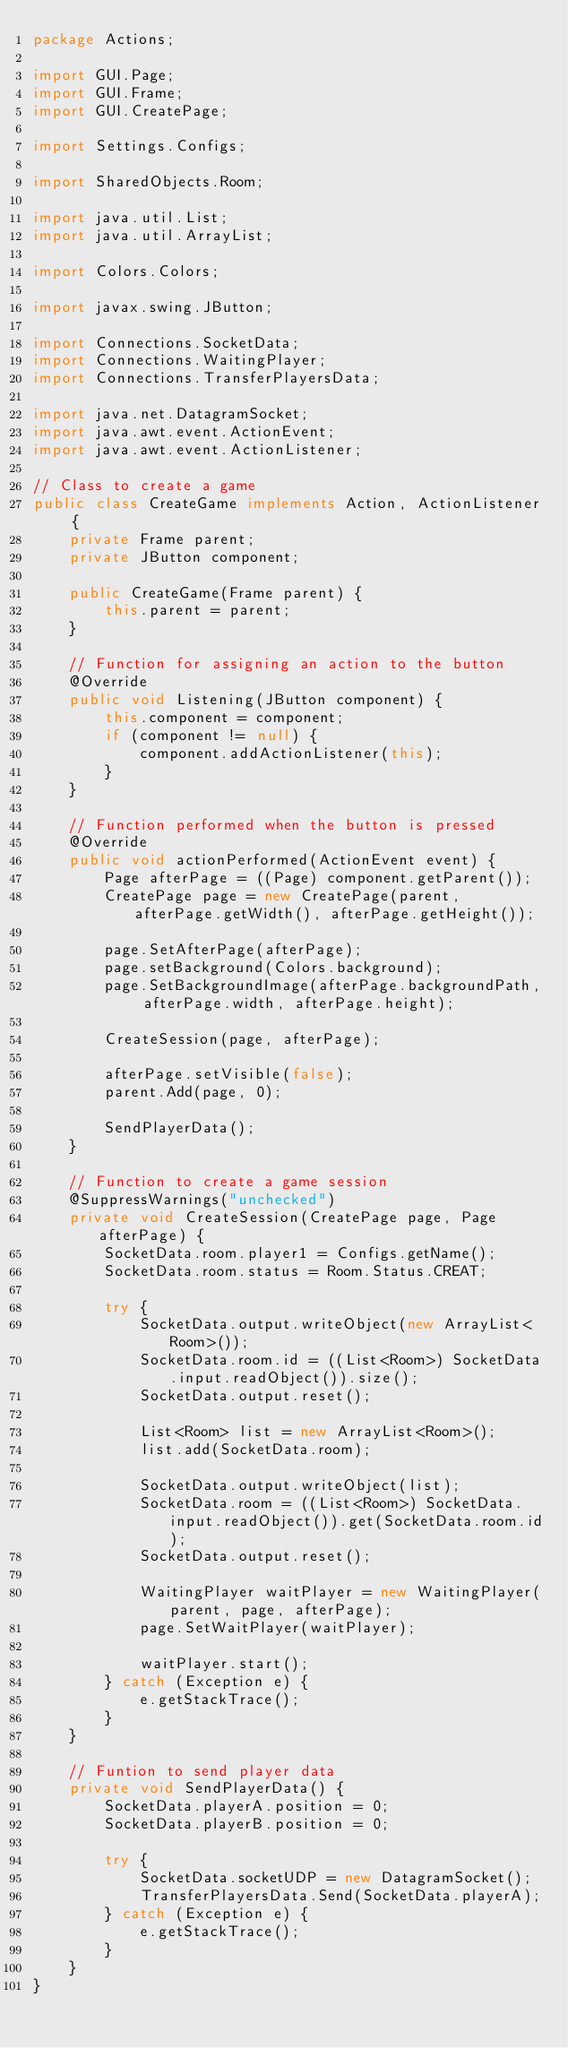Convert code to text. <code><loc_0><loc_0><loc_500><loc_500><_Java_>package Actions;

import GUI.Page;
import GUI.Frame;
import GUI.CreatePage;

import Settings.Configs;

import SharedObjects.Room;

import java.util.List;
import java.util.ArrayList;

import Colors.Colors;

import javax.swing.JButton;

import Connections.SocketData;
import Connections.WaitingPlayer;
import Connections.TransferPlayersData;

import java.net.DatagramSocket;
import java.awt.event.ActionEvent;
import java.awt.event.ActionListener;

// Class to create a game
public class CreateGame implements Action, ActionListener {
    private Frame parent;
    private JButton component;

    public CreateGame(Frame parent) {
        this.parent = parent;
    }

    // Function for assigning an action to the button
    @Override
    public void Listening(JButton component) {
        this.component = component;
        if (component != null) {
            component.addActionListener(this);
        }
    }

    // Function performed when the button is pressed
    @Override
    public void actionPerformed(ActionEvent event) {
        Page afterPage = ((Page) component.getParent());
        CreatePage page = new CreatePage(parent, afterPage.getWidth(), afterPage.getHeight());

        page.SetAfterPage(afterPage);
        page.setBackground(Colors.background);
        page.SetBackgroundImage(afterPage.backgroundPath, afterPage.width, afterPage.height);

        CreateSession(page, afterPage);

        afterPage.setVisible(false);
        parent.Add(page, 0);

        SendPlayerData();
    }

    // Function to create a game session
    @SuppressWarnings("unchecked")
    private void CreateSession(CreatePage page, Page afterPage) {
        SocketData.room.player1 = Configs.getName();
        SocketData.room.status = Room.Status.CREAT;

        try {
            SocketData.output.writeObject(new ArrayList<Room>());
            SocketData.room.id = ((List<Room>) SocketData.input.readObject()).size();
            SocketData.output.reset();

            List<Room> list = new ArrayList<Room>();
            list.add(SocketData.room);

            SocketData.output.writeObject(list);
            SocketData.room = ((List<Room>) SocketData.input.readObject()).get(SocketData.room.id);
            SocketData.output.reset();

            WaitingPlayer waitPlayer = new WaitingPlayer(parent, page, afterPage);
            page.SetWaitPlayer(waitPlayer);

            waitPlayer.start();
        } catch (Exception e) {
            e.getStackTrace();
        }
    }

    // Funtion to send player data
    private void SendPlayerData() {
        SocketData.playerA.position = 0;
        SocketData.playerB.position = 0;

        try {
            SocketData.socketUDP = new DatagramSocket();
            TransferPlayersData.Send(SocketData.playerA);
        } catch (Exception e) {
            e.getStackTrace();
        }
    }
}
</code> 